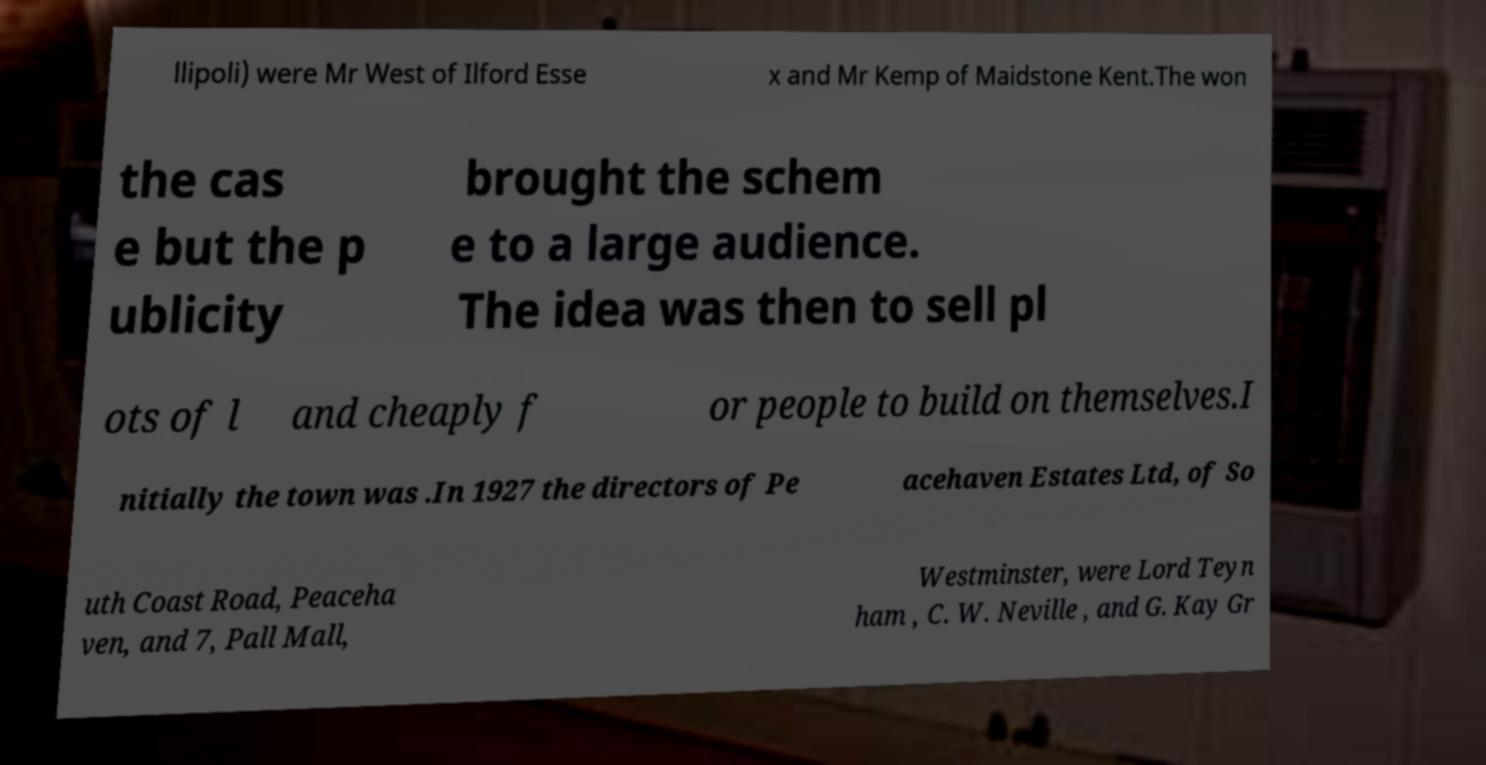Please identify and transcribe the text found in this image. llipoli) were Mr West of Ilford Esse x and Mr Kemp of Maidstone Kent.The won the cas e but the p ublicity brought the schem e to a large audience. The idea was then to sell pl ots of l and cheaply f or people to build on themselves.I nitially the town was .In 1927 the directors of Pe acehaven Estates Ltd, of So uth Coast Road, Peaceha ven, and 7, Pall Mall, Westminster, were Lord Teyn ham , C. W. Neville , and G. Kay Gr 